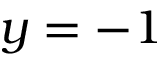Convert formula to latex. <formula><loc_0><loc_0><loc_500><loc_500>y = - 1</formula> 